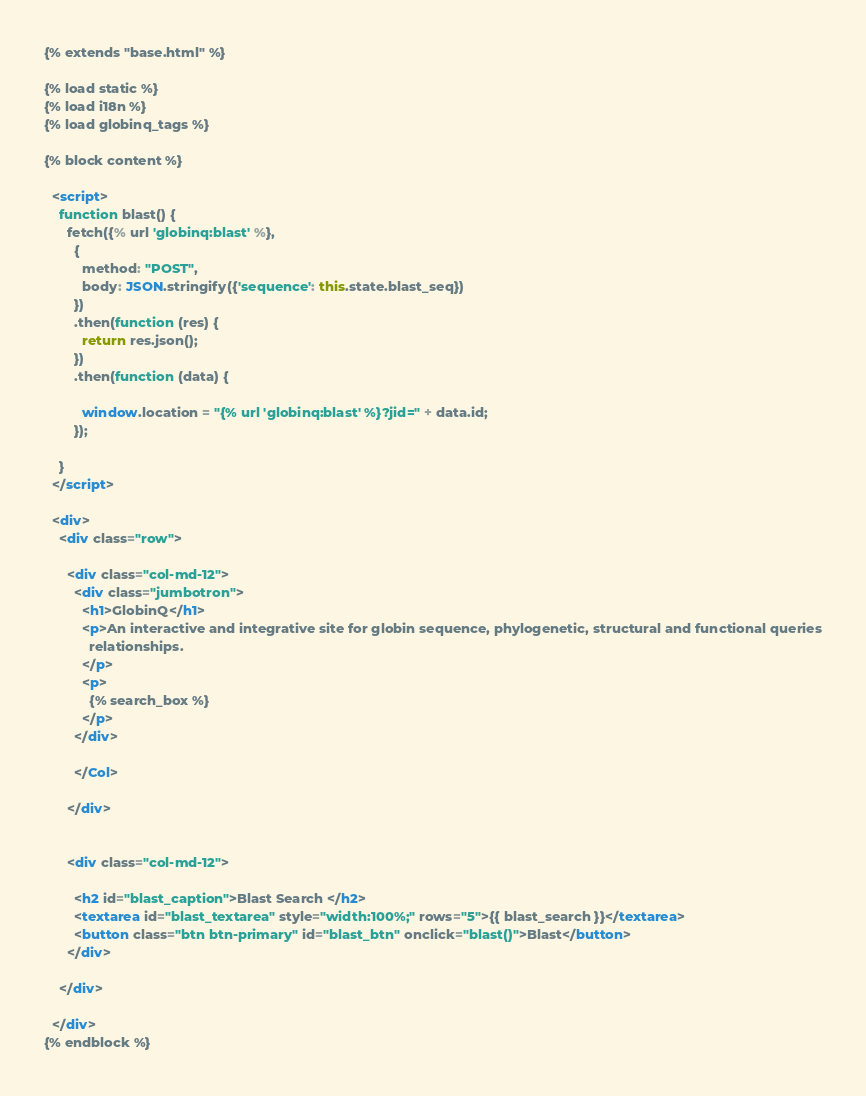<code> <loc_0><loc_0><loc_500><loc_500><_HTML_>{% extends "base.html" %}

{% load static %}
{% load i18n %}
{% load globinq_tags %}

{% block content %}

  <script>
    function blast() {
      fetch({% url 'globinq:blast' %},
        {
          method: "POST",
          body: JSON.stringify({'sequence': this.state.blast_seq})
        })
        .then(function (res) {
          return res.json();
        })
        .then(function (data) {

          window.location = "{% url 'globinq:blast' %}?jid=" + data.id;
        });

    }
  </script>

  <div>
    <div class="row">

      <div class="col-md-12">
        <div class="jumbotron">
          <h1>GlobinQ</h1>
          <p>An interactive and integrative site for globin sequence, phylogenetic, structural and functional queries
            relationships.
          </p>
          <p>
            {% search_box %}
          </p>
        </div>

        </Col>

      </div>


      <div class="col-md-12">

        <h2 id="blast_caption">Blast Search </h2>
        <textarea id="blast_textarea" style="width:100%;" rows="5">{{ blast_search }}</textarea>
        <button class="btn btn-primary" id="blast_btn" onclick="blast()">Blast</button>
      </div>

    </div>

  </div>
{% endblock %}
</code> 